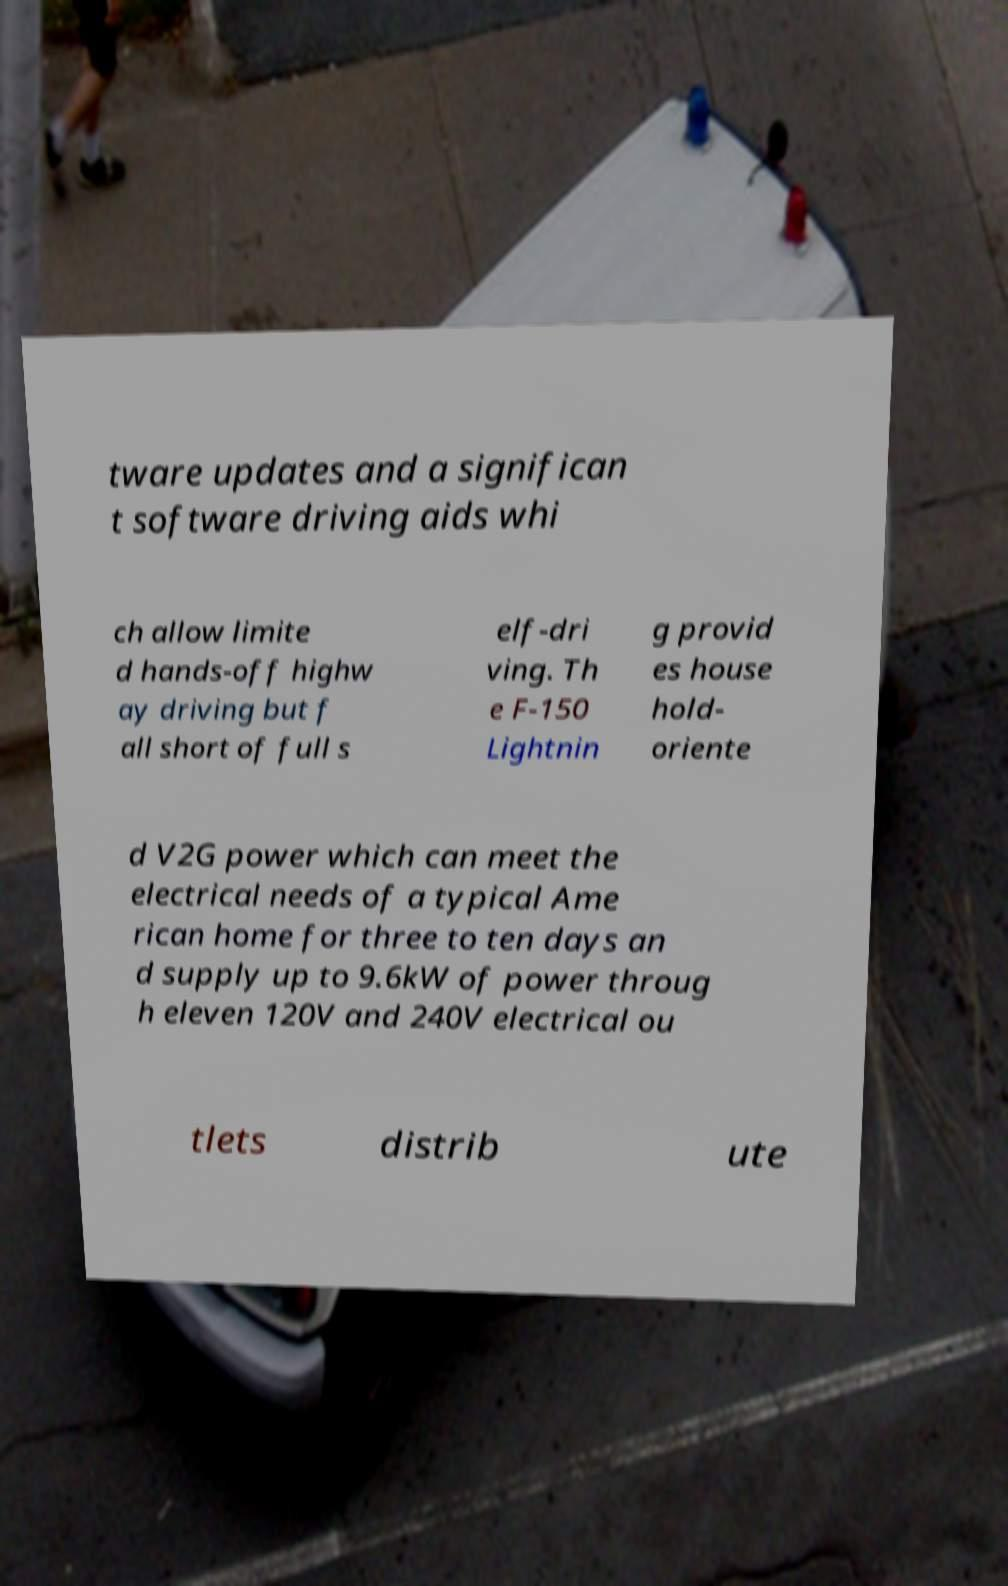I need the written content from this picture converted into text. Can you do that? tware updates and a significan t software driving aids whi ch allow limite d hands-off highw ay driving but f all short of full s elf-dri ving. Th e F-150 Lightnin g provid es house hold- oriente d V2G power which can meet the electrical needs of a typical Ame rican home for three to ten days an d supply up to 9.6kW of power throug h eleven 120V and 240V electrical ou tlets distrib ute 